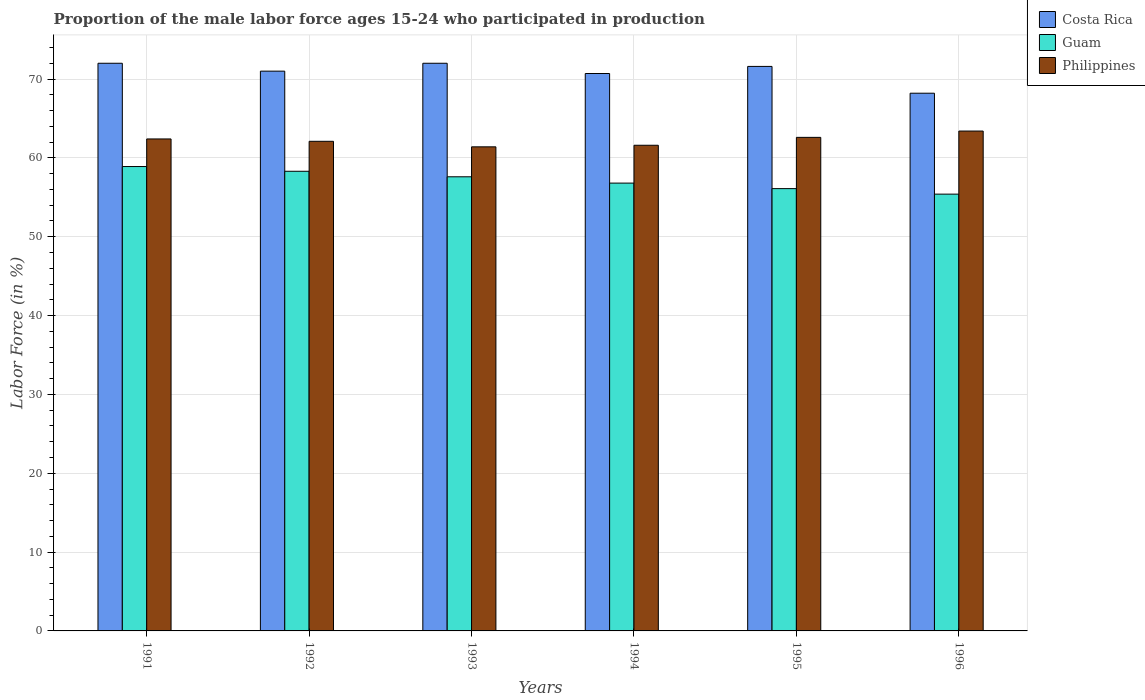How many different coloured bars are there?
Provide a succinct answer. 3. How many groups of bars are there?
Your answer should be very brief. 6. How many bars are there on the 2nd tick from the left?
Offer a very short reply. 3. How many bars are there on the 2nd tick from the right?
Make the answer very short. 3. What is the label of the 4th group of bars from the left?
Keep it short and to the point. 1994. What is the proportion of the male labor force who participated in production in Philippines in 1996?
Offer a terse response. 63.4. Across all years, what is the maximum proportion of the male labor force who participated in production in Guam?
Your answer should be very brief. 58.9. Across all years, what is the minimum proportion of the male labor force who participated in production in Philippines?
Offer a terse response. 61.4. In which year was the proportion of the male labor force who participated in production in Guam maximum?
Offer a terse response. 1991. In which year was the proportion of the male labor force who participated in production in Costa Rica minimum?
Ensure brevity in your answer.  1996. What is the total proportion of the male labor force who participated in production in Philippines in the graph?
Provide a short and direct response. 373.5. What is the difference between the proportion of the male labor force who participated in production in Costa Rica in 1996 and the proportion of the male labor force who participated in production in Philippines in 1995?
Offer a very short reply. 5.6. What is the average proportion of the male labor force who participated in production in Guam per year?
Offer a very short reply. 57.18. In the year 1991, what is the difference between the proportion of the male labor force who participated in production in Costa Rica and proportion of the male labor force who participated in production in Guam?
Ensure brevity in your answer.  13.1. What is the ratio of the proportion of the male labor force who participated in production in Costa Rica in 1992 to that in 1994?
Give a very brief answer. 1. Is the proportion of the male labor force who participated in production in Philippines in 1993 less than that in 1994?
Offer a very short reply. Yes. What is the difference between the highest and the second highest proportion of the male labor force who participated in production in Philippines?
Give a very brief answer. 0.8. What is the difference between the highest and the lowest proportion of the male labor force who participated in production in Costa Rica?
Offer a very short reply. 3.8. In how many years, is the proportion of the male labor force who participated in production in Guam greater than the average proportion of the male labor force who participated in production in Guam taken over all years?
Ensure brevity in your answer.  3. What does the 2nd bar from the right in 1991 represents?
Ensure brevity in your answer.  Guam. Is it the case that in every year, the sum of the proportion of the male labor force who participated in production in Guam and proportion of the male labor force who participated in production in Costa Rica is greater than the proportion of the male labor force who participated in production in Philippines?
Your response must be concise. Yes. Does the graph contain grids?
Keep it short and to the point. Yes. Where does the legend appear in the graph?
Your answer should be compact. Top right. How many legend labels are there?
Keep it short and to the point. 3. How are the legend labels stacked?
Offer a terse response. Vertical. What is the title of the graph?
Ensure brevity in your answer.  Proportion of the male labor force ages 15-24 who participated in production. Does "Euro area" appear as one of the legend labels in the graph?
Make the answer very short. No. What is the label or title of the X-axis?
Provide a short and direct response. Years. What is the Labor Force (in %) in Guam in 1991?
Your response must be concise. 58.9. What is the Labor Force (in %) in Philippines in 1991?
Your answer should be very brief. 62.4. What is the Labor Force (in %) in Costa Rica in 1992?
Your response must be concise. 71. What is the Labor Force (in %) in Guam in 1992?
Your answer should be very brief. 58.3. What is the Labor Force (in %) in Philippines in 1992?
Give a very brief answer. 62.1. What is the Labor Force (in %) in Costa Rica in 1993?
Offer a very short reply. 72. What is the Labor Force (in %) of Guam in 1993?
Offer a very short reply. 57.6. What is the Labor Force (in %) in Philippines in 1993?
Provide a succinct answer. 61.4. What is the Labor Force (in %) of Costa Rica in 1994?
Your response must be concise. 70.7. What is the Labor Force (in %) of Guam in 1994?
Provide a short and direct response. 56.8. What is the Labor Force (in %) in Philippines in 1994?
Provide a succinct answer. 61.6. What is the Labor Force (in %) in Costa Rica in 1995?
Keep it short and to the point. 71.6. What is the Labor Force (in %) in Guam in 1995?
Provide a succinct answer. 56.1. What is the Labor Force (in %) of Philippines in 1995?
Your response must be concise. 62.6. What is the Labor Force (in %) of Costa Rica in 1996?
Provide a succinct answer. 68.2. What is the Labor Force (in %) of Guam in 1996?
Keep it short and to the point. 55.4. What is the Labor Force (in %) of Philippines in 1996?
Provide a succinct answer. 63.4. Across all years, what is the maximum Labor Force (in %) of Guam?
Your answer should be compact. 58.9. Across all years, what is the maximum Labor Force (in %) in Philippines?
Make the answer very short. 63.4. Across all years, what is the minimum Labor Force (in %) in Costa Rica?
Make the answer very short. 68.2. Across all years, what is the minimum Labor Force (in %) in Guam?
Offer a very short reply. 55.4. Across all years, what is the minimum Labor Force (in %) of Philippines?
Offer a very short reply. 61.4. What is the total Labor Force (in %) in Costa Rica in the graph?
Provide a succinct answer. 425.5. What is the total Labor Force (in %) in Guam in the graph?
Give a very brief answer. 343.1. What is the total Labor Force (in %) in Philippines in the graph?
Give a very brief answer. 373.5. What is the difference between the Labor Force (in %) in Guam in 1991 and that in 1993?
Give a very brief answer. 1.3. What is the difference between the Labor Force (in %) in Costa Rica in 1991 and that in 1995?
Keep it short and to the point. 0.4. What is the difference between the Labor Force (in %) of Philippines in 1991 and that in 1996?
Give a very brief answer. -1. What is the difference between the Labor Force (in %) of Costa Rica in 1992 and that in 1993?
Make the answer very short. -1. What is the difference between the Labor Force (in %) of Guam in 1992 and that in 1993?
Give a very brief answer. 0.7. What is the difference between the Labor Force (in %) of Philippines in 1992 and that in 1993?
Make the answer very short. 0.7. What is the difference between the Labor Force (in %) in Costa Rica in 1992 and that in 1994?
Your answer should be very brief. 0.3. What is the difference between the Labor Force (in %) of Guam in 1992 and that in 1994?
Your response must be concise. 1.5. What is the difference between the Labor Force (in %) of Philippines in 1992 and that in 1994?
Ensure brevity in your answer.  0.5. What is the difference between the Labor Force (in %) in Costa Rica in 1992 and that in 1995?
Ensure brevity in your answer.  -0.6. What is the difference between the Labor Force (in %) in Guam in 1992 and that in 1995?
Provide a succinct answer. 2.2. What is the difference between the Labor Force (in %) in Costa Rica in 1992 and that in 1996?
Ensure brevity in your answer.  2.8. What is the difference between the Labor Force (in %) in Philippines in 1992 and that in 1996?
Keep it short and to the point. -1.3. What is the difference between the Labor Force (in %) of Costa Rica in 1993 and that in 1994?
Ensure brevity in your answer.  1.3. What is the difference between the Labor Force (in %) of Guam in 1993 and that in 1994?
Keep it short and to the point. 0.8. What is the difference between the Labor Force (in %) of Guam in 1993 and that in 1995?
Your answer should be very brief. 1.5. What is the difference between the Labor Force (in %) of Philippines in 1993 and that in 1995?
Provide a succinct answer. -1.2. What is the difference between the Labor Force (in %) in Philippines in 1994 and that in 1995?
Keep it short and to the point. -1. What is the difference between the Labor Force (in %) in Philippines in 1994 and that in 1996?
Ensure brevity in your answer.  -1.8. What is the difference between the Labor Force (in %) in Guam in 1991 and the Labor Force (in %) in Philippines in 1992?
Offer a terse response. -3.2. What is the difference between the Labor Force (in %) in Costa Rica in 1991 and the Labor Force (in %) in Guam in 1993?
Provide a succinct answer. 14.4. What is the difference between the Labor Force (in %) in Costa Rica in 1991 and the Labor Force (in %) in Philippines in 1993?
Offer a terse response. 10.6. What is the difference between the Labor Force (in %) of Costa Rica in 1991 and the Labor Force (in %) of Philippines in 1994?
Offer a terse response. 10.4. What is the difference between the Labor Force (in %) of Guam in 1991 and the Labor Force (in %) of Philippines in 1994?
Your answer should be very brief. -2.7. What is the difference between the Labor Force (in %) in Costa Rica in 1991 and the Labor Force (in %) in Philippines in 1995?
Your answer should be very brief. 9.4. What is the difference between the Labor Force (in %) in Costa Rica in 1991 and the Labor Force (in %) in Guam in 1996?
Offer a terse response. 16.6. What is the difference between the Labor Force (in %) in Costa Rica in 1991 and the Labor Force (in %) in Philippines in 1996?
Make the answer very short. 8.6. What is the difference between the Labor Force (in %) in Guam in 1991 and the Labor Force (in %) in Philippines in 1996?
Provide a succinct answer. -4.5. What is the difference between the Labor Force (in %) of Costa Rica in 1992 and the Labor Force (in %) of Guam in 1993?
Offer a very short reply. 13.4. What is the difference between the Labor Force (in %) of Costa Rica in 1992 and the Labor Force (in %) of Philippines in 1993?
Your answer should be compact. 9.6. What is the difference between the Labor Force (in %) of Guam in 1992 and the Labor Force (in %) of Philippines in 1993?
Provide a succinct answer. -3.1. What is the difference between the Labor Force (in %) of Costa Rica in 1992 and the Labor Force (in %) of Philippines in 1994?
Make the answer very short. 9.4. What is the difference between the Labor Force (in %) of Costa Rica in 1992 and the Labor Force (in %) of Philippines in 1995?
Make the answer very short. 8.4. What is the difference between the Labor Force (in %) in Costa Rica in 1992 and the Labor Force (in %) in Guam in 1996?
Make the answer very short. 15.6. What is the difference between the Labor Force (in %) in Costa Rica in 1992 and the Labor Force (in %) in Philippines in 1996?
Keep it short and to the point. 7.6. What is the difference between the Labor Force (in %) of Costa Rica in 1993 and the Labor Force (in %) of Philippines in 1994?
Your answer should be compact. 10.4. What is the difference between the Labor Force (in %) in Costa Rica in 1993 and the Labor Force (in %) in Philippines in 1996?
Give a very brief answer. 8.6. What is the difference between the Labor Force (in %) of Costa Rica in 1994 and the Labor Force (in %) of Philippines in 1995?
Your response must be concise. 8.1. What is the difference between the Labor Force (in %) in Guam in 1994 and the Labor Force (in %) in Philippines in 1995?
Offer a very short reply. -5.8. What is the difference between the Labor Force (in %) of Costa Rica in 1994 and the Labor Force (in %) of Philippines in 1996?
Make the answer very short. 7.3. What is the difference between the Labor Force (in %) in Costa Rica in 1995 and the Labor Force (in %) in Guam in 1996?
Make the answer very short. 16.2. What is the difference between the Labor Force (in %) in Guam in 1995 and the Labor Force (in %) in Philippines in 1996?
Your answer should be compact. -7.3. What is the average Labor Force (in %) of Costa Rica per year?
Your answer should be very brief. 70.92. What is the average Labor Force (in %) of Guam per year?
Offer a very short reply. 57.18. What is the average Labor Force (in %) in Philippines per year?
Ensure brevity in your answer.  62.25. In the year 1991, what is the difference between the Labor Force (in %) in Costa Rica and Labor Force (in %) in Guam?
Your answer should be very brief. 13.1. In the year 1991, what is the difference between the Labor Force (in %) in Costa Rica and Labor Force (in %) in Philippines?
Your answer should be very brief. 9.6. In the year 1992, what is the difference between the Labor Force (in %) in Costa Rica and Labor Force (in %) in Guam?
Provide a short and direct response. 12.7. In the year 1992, what is the difference between the Labor Force (in %) of Guam and Labor Force (in %) of Philippines?
Your answer should be compact. -3.8. In the year 1993, what is the difference between the Labor Force (in %) in Costa Rica and Labor Force (in %) in Guam?
Offer a very short reply. 14.4. In the year 1993, what is the difference between the Labor Force (in %) in Costa Rica and Labor Force (in %) in Philippines?
Ensure brevity in your answer.  10.6. In the year 1994, what is the difference between the Labor Force (in %) of Costa Rica and Labor Force (in %) of Guam?
Your response must be concise. 13.9. In the year 1996, what is the difference between the Labor Force (in %) in Costa Rica and Labor Force (in %) in Guam?
Your answer should be compact. 12.8. In the year 1996, what is the difference between the Labor Force (in %) in Costa Rica and Labor Force (in %) in Philippines?
Offer a terse response. 4.8. What is the ratio of the Labor Force (in %) in Costa Rica in 1991 to that in 1992?
Your response must be concise. 1.01. What is the ratio of the Labor Force (in %) of Guam in 1991 to that in 1992?
Ensure brevity in your answer.  1.01. What is the ratio of the Labor Force (in %) in Philippines in 1991 to that in 1992?
Your response must be concise. 1. What is the ratio of the Labor Force (in %) of Guam in 1991 to that in 1993?
Ensure brevity in your answer.  1.02. What is the ratio of the Labor Force (in %) in Philippines in 1991 to that in 1993?
Offer a terse response. 1.02. What is the ratio of the Labor Force (in %) in Costa Rica in 1991 to that in 1994?
Provide a short and direct response. 1.02. What is the ratio of the Labor Force (in %) of Costa Rica in 1991 to that in 1995?
Your answer should be compact. 1.01. What is the ratio of the Labor Force (in %) in Guam in 1991 to that in 1995?
Your answer should be compact. 1.05. What is the ratio of the Labor Force (in %) in Philippines in 1991 to that in 1995?
Give a very brief answer. 1. What is the ratio of the Labor Force (in %) in Costa Rica in 1991 to that in 1996?
Offer a terse response. 1.06. What is the ratio of the Labor Force (in %) in Guam in 1991 to that in 1996?
Make the answer very short. 1.06. What is the ratio of the Labor Force (in %) in Philippines in 1991 to that in 1996?
Ensure brevity in your answer.  0.98. What is the ratio of the Labor Force (in %) in Costa Rica in 1992 to that in 1993?
Offer a very short reply. 0.99. What is the ratio of the Labor Force (in %) in Guam in 1992 to that in 1993?
Your answer should be compact. 1.01. What is the ratio of the Labor Force (in %) of Philippines in 1992 to that in 1993?
Keep it short and to the point. 1.01. What is the ratio of the Labor Force (in %) in Costa Rica in 1992 to that in 1994?
Provide a succinct answer. 1. What is the ratio of the Labor Force (in %) of Guam in 1992 to that in 1994?
Give a very brief answer. 1.03. What is the ratio of the Labor Force (in %) of Guam in 1992 to that in 1995?
Provide a short and direct response. 1.04. What is the ratio of the Labor Force (in %) in Philippines in 1992 to that in 1995?
Give a very brief answer. 0.99. What is the ratio of the Labor Force (in %) in Costa Rica in 1992 to that in 1996?
Offer a terse response. 1.04. What is the ratio of the Labor Force (in %) in Guam in 1992 to that in 1996?
Your answer should be compact. 1.05. What is the ratio of the Labor Force (in %) of Philippines in 1992 to that in 1996?
Your answer should be very brief. 0.98. What is the ratio of the Labor Force (in %) in Costa Rica in 1993 to that in 1994?
Your answer should be compact. 1.02. What is the ratio of the Labor Force (in %) of Guam in 1993 to that in 1994?
Provide a short and direct response. 1.01. What is the ratio of the Labor Force (in %) of Philippines in 1993 to that in 1994?
Give a very brief answer. 1. What is the ratio of the Labor Force (in %) in Costa Rica in 1993 to that in 1995?
Your answer should be compact. 1.01. What is the ratio of the Labor Force (in %) of Guam in 1993 to that in 1995?
Make the answer very short. 1.03. What is the ratio of the Labor Force (in %) of Philippines in 1993 to that in 1995?
Offer a terse response. 0.98. What is the ratio of the Labor Force (in %) in Costa Rica in 1993 to that in 1996?
Offer a very short reply. 1.06. What is the ratio of the Labor Force (in %) in Guam in 1993 to that in 1996?
Make the answer very short. 1.04. What is the ratio of the Labor Force (in %) of Philippines in 1993 to that in 1996?
Your answer should be compact. 0.97. What is the ratio of the Labor Force (in %) in Costa Rica in 1994 to that in 1995?
Your response must be concise. 0.99. What is the ratio of the Labor Force (in %) of Guam in 1994 to that in 1995?
Your response must be concise. 1.01. What is the ratio of the Labor Force (in %) in Philippines in 1994 to that in 1995?
Ensure brevity in your answer.  0.98. What is the ratio of the Labor Force (in %) in Costa Rica in 1994 to that in 1996?
Your response must be concise. 1.04. What is the ratio of the Labor Force (in %) in Guam in 1994 to that in 1996?
Ensure brevity in your answer.  1.03. What is the ratio of the Labor Force (in %) of Philippines in 1994 to that in 1996?
Make the answer very short. 0.97. What is the ratio of the Labor Force (in %) in Costa Rica in 1995 to that in 1996?
Give a very brief answer. 1.05. What is the ratio of the Labor Force (in %) in Guam in 1995 to that in 1996?
Offer a terse response. 1.01. What is the ratio of the Labor Force (in %) of Philippines in 1995 to that in 1996?
Make the answer very short. 0.99. What is the difference between the highest and the lowest Labor Force (in %) of Costa Rica?
Make the answer very short. 3.8. What is the difference between the highest and the lowest Labor Force (in %) in Guam?
Keep it short and to the point. 3.5. 